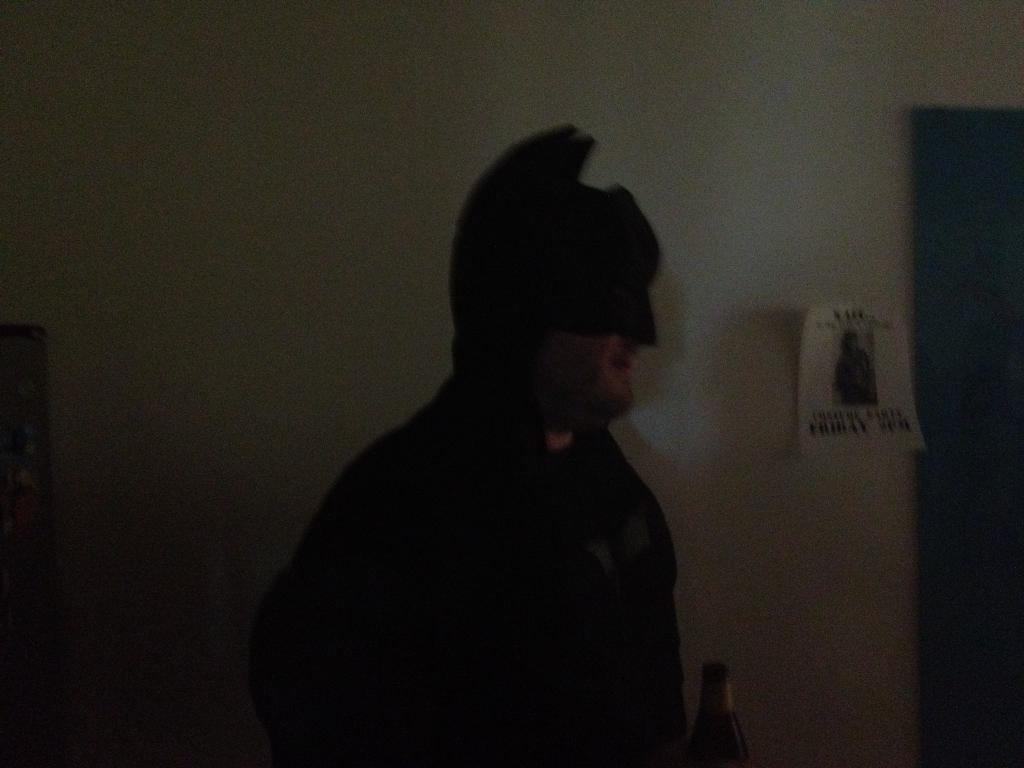Who is in the image? There is a man in the image. What is the man wearing? The man is dressed in a batman costume. What can be seen in the background of the image? There is a wall in the background of the image. What is on the wall? There is a poster on the wall. What other object is present in the image? There is a wine bottle in the image. What type of sign is the beast holding in the image? There is no beast or sign present in the image; it features a man dressed in a batman costume. 